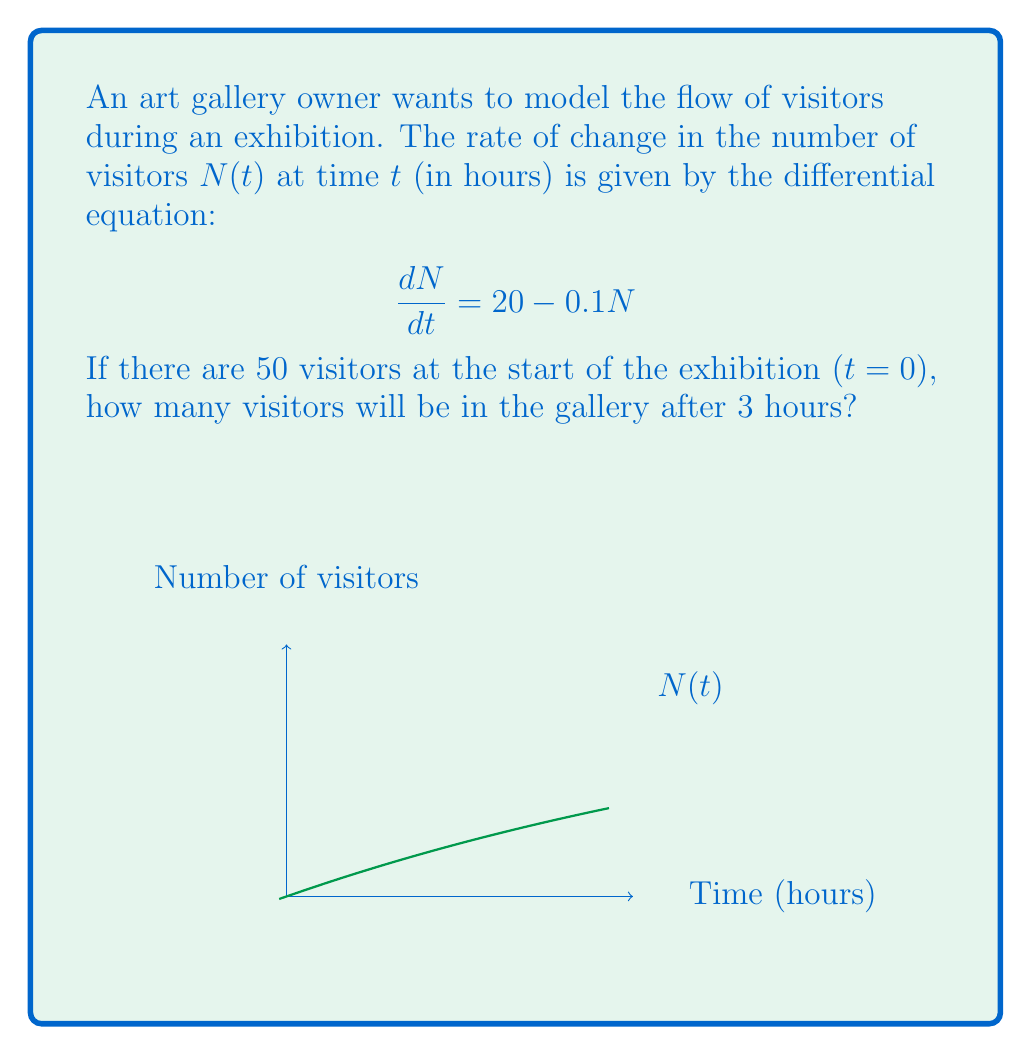Show me your answer to this math problem. Let's solve this step-by-step:

1) The given differential equation is:
   $$\frac{dN}{dt} = 20 - 0.1N$$

2) This is a linear first-order differential equation. The general solution is:
   $$N(t) = 200 + Ce^{-0.1t}$$
   where $C$ is a constant to be determined from the initial condition.

3) We're given that $N(0) = 50$. Let's use this to find $C$:
   $$50 = 200 + C$$
   $$C = -150$$

4) So, our particular solution is:
   $$N(t) = 200 - 150e^{-0.1t}$$

5) To find the number of visitors after 3 hours, we evaluate $N(3)$:
   $$N(3) = 200 - 150e^{-0.1(3)}$$
   $$= 200 - 150e^{-0.3}$$
   $$\approx 200 - 150(0.7408)$$
   $$\approx 200 - 111.12$$
   $$\approx 88.88$$

6) Rounding to the nearest whole number (as we can't have fractional visitors), we get 89 visitors.
Answer: 89 visitors 